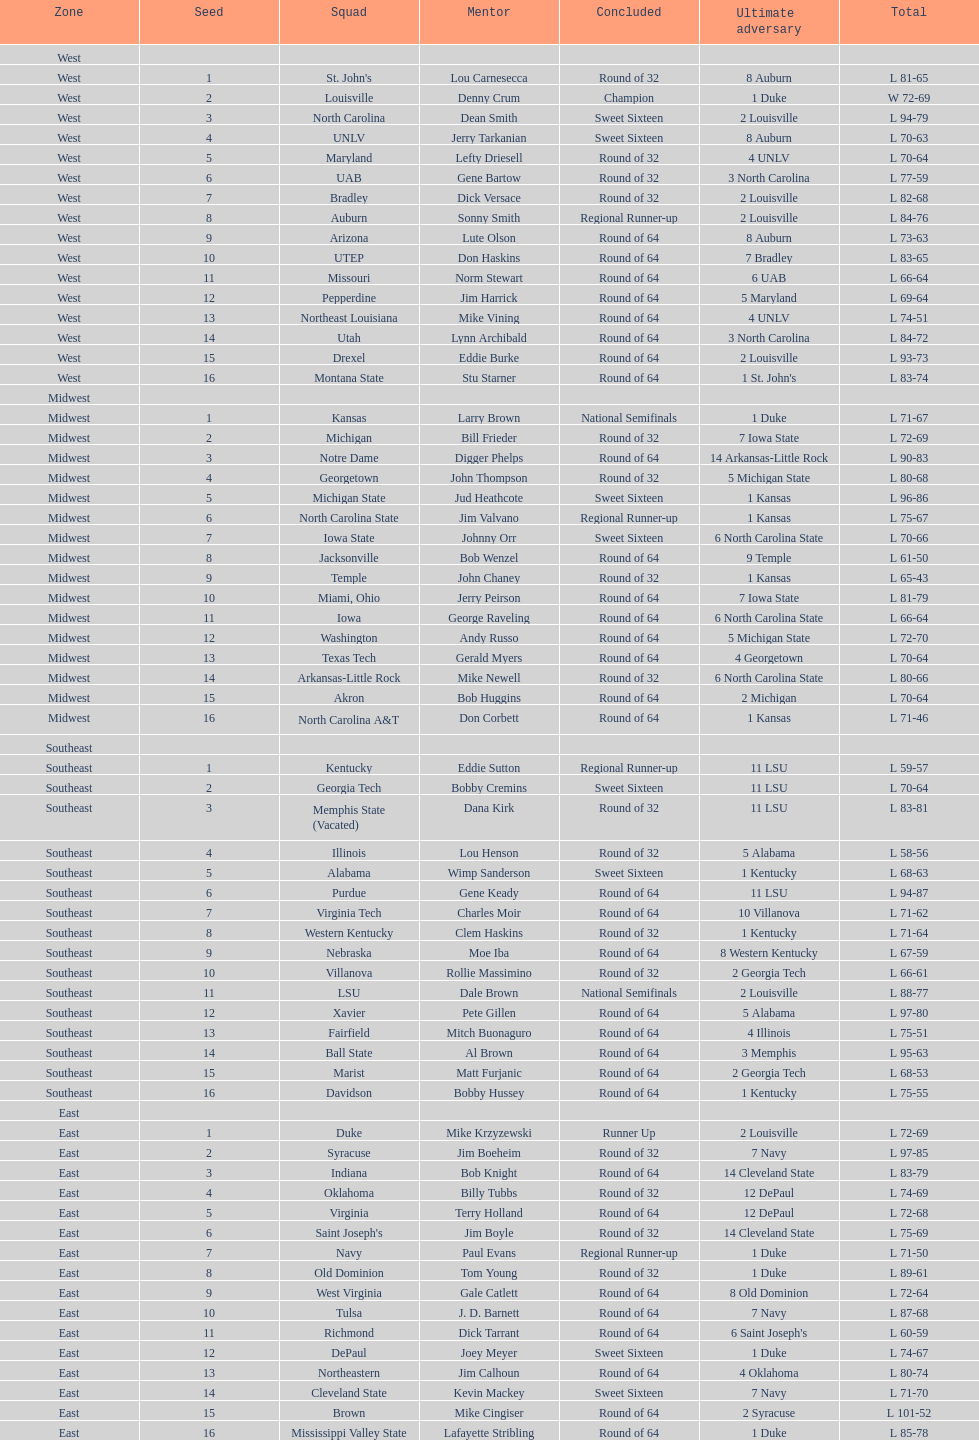Who is the only team from the east region to reach the final round? Duke. 